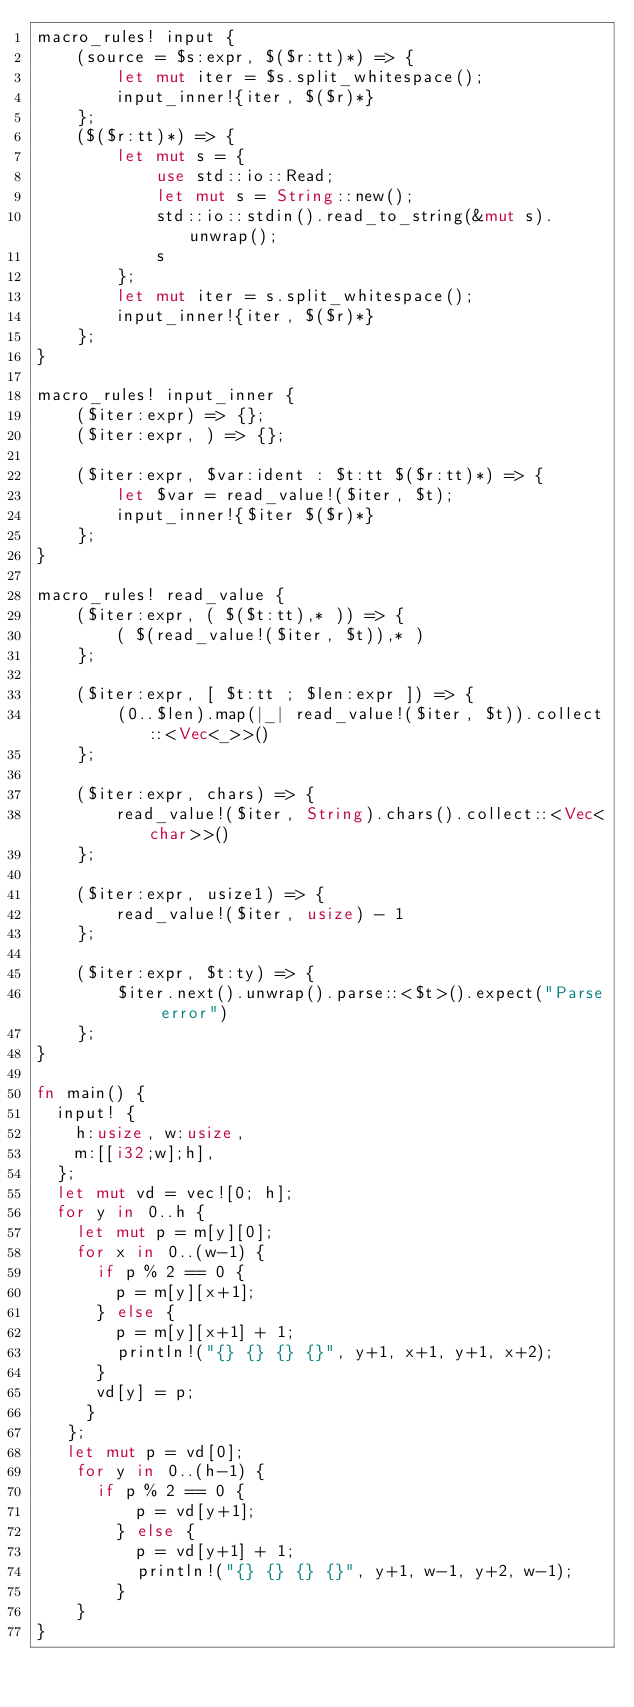Convert code to text. <code><loc_0><loc_0><loc_500><loc_500><_Rust_>macro_rules! input {
    (source = $s:expr, $($r:tt)*) => {
        let mut iter = $s.split_whitespace();
        input_inner!{iter, $($r)*}
    };
    ($($r:tt)*) => {
        let mut s = {
            use std::io::Read;
            let mut s = String::new();
            std::io::stdin().read_to_string(&mut s).unwrap();
            s
        };
        let mut iter = s.split_whitespace();
        input_inner!{iter, $($r)*}
    };
}

macro_rules! input_inner {
    ($iter:expr) => {};
    ($iter:expr, ) => {};

    ($iter:expr, $var:ident : $t:tt $($r:tt)*) => {
        let $var = read_value!($iter, $t);
        input_inner!{$iter $($r)*}
    };
}

macro_rules! read_value {
    ($iter:expr, ( $($t:tt),* )) => {
        ( $(read_value!($iter, $t)),* )
    };

    ($iter:expr, [ $t:tt ; $len:expr ]) => {
        (0..$len).map(|_| read_value!($iter, $t)).collect::<Vec<_>>()
    };

    ($iter:expr, chars) => {
        read_value!($iter, String).chars().collect::<Vec<char>>()
    };

    ($iter:expr, usize1) => {
        read_value!($iter, usize) - 1
    };

    ($iter:expr, $t:ty) => {
        $iter.next().unwrap().parse::<$t>().expect("Parse error")
    };
}

fn main() {
  input! {
    h:usize, w:usize,
    m:[[i32;w];h],
  };
  let mut vd = vec![0; h];
  for y in 0..h {
    let mut p = m[y][0];
    for x in 0..(w-1) {
      if p % 2 == 0 {
        p = m[y][x+1];
      } else { 
        p = m[y][x+1] + 1;
        println!("{} {} {} {}", y+1, x+1, y+1, x+2);
      }
      vd[y] = p;
     }
   };
   let mut p = vd[0];
    for y in 0..(h-1) {
      if p % 2 == 0 {
          p = vd[y+1];
        } else { 
          p = vd[y+1] + 1;
          println!("{} {} {} {}", y+1, w-1, y+2, w-1);
        }
    }
}</code> 